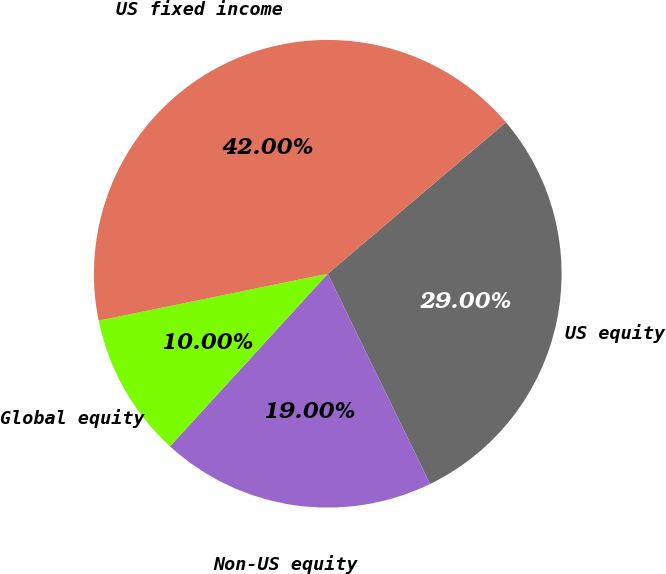Convert chart. <chart><loc_0><loc_0><loc_500><loc_500><pie_chart><fcel>US equity<fcel>Non-US equity<fcel>Global equity<fcel>US fixed income<nl><fcel>29.0%<fcel>19.0%<fcel>10.0%<fcel>42.0%<nl></chart> 